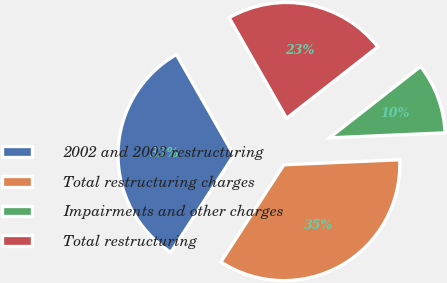<chart> <loc_0><loc_0><loc_500><loc_500><pie_chart><fcel>2002 and 2003 restructuring<fcel>Total restructuring charges<fcel>Impairments and other charges<fcel>Total restructuring<nl><fcel>32.58%<fcel>34.85%<fcel>9.89%<fcel>22.69%<nl></chart> 